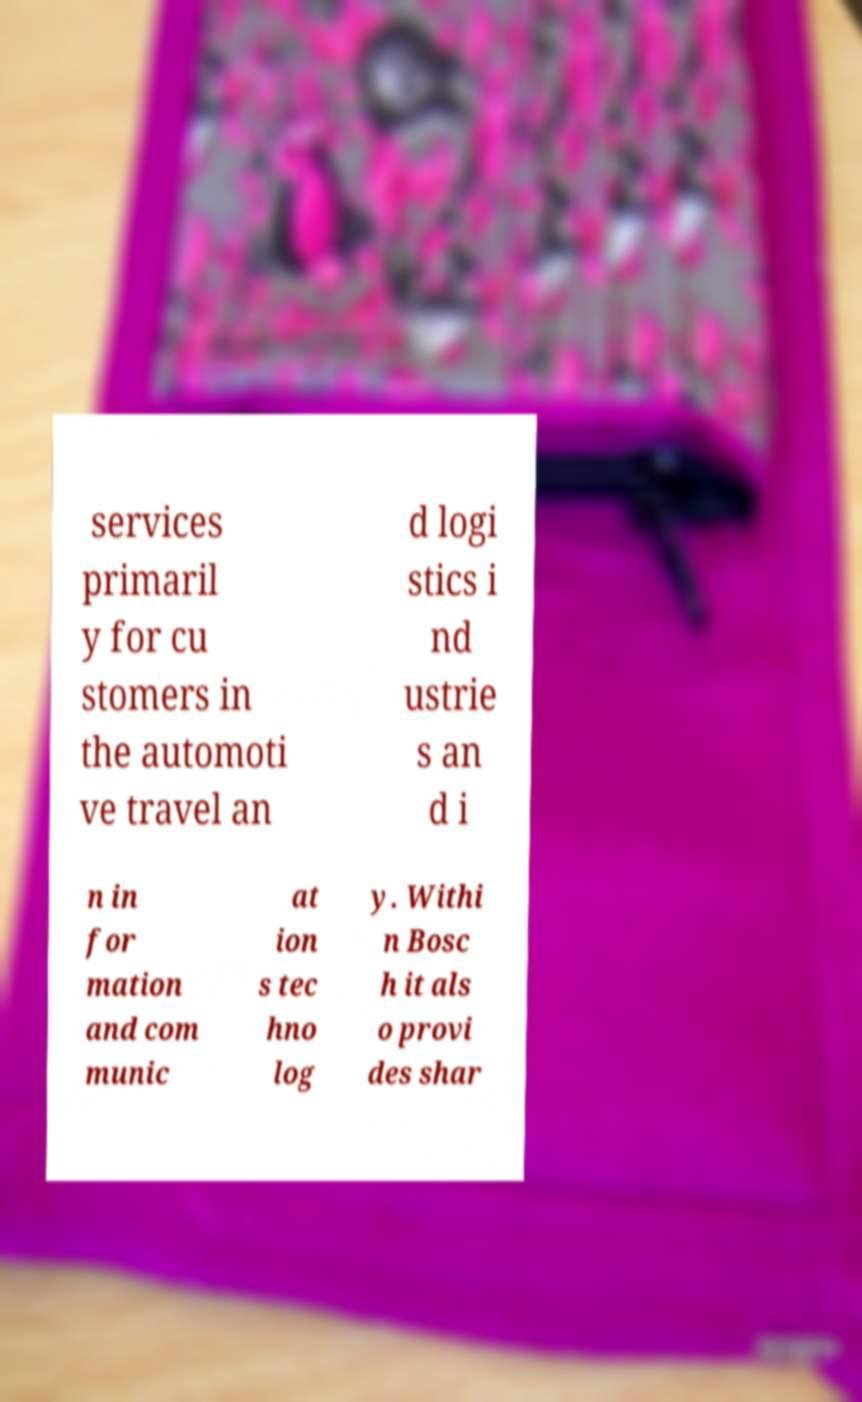Could you extract and type out the text from this image? services primaril y for cu stomers in the automoti ve travel an d logi stics i nd ustrie s an d i n in for mation and com munic at ion s tec hno log y. Withi n Bosc h it als o provi des shar 